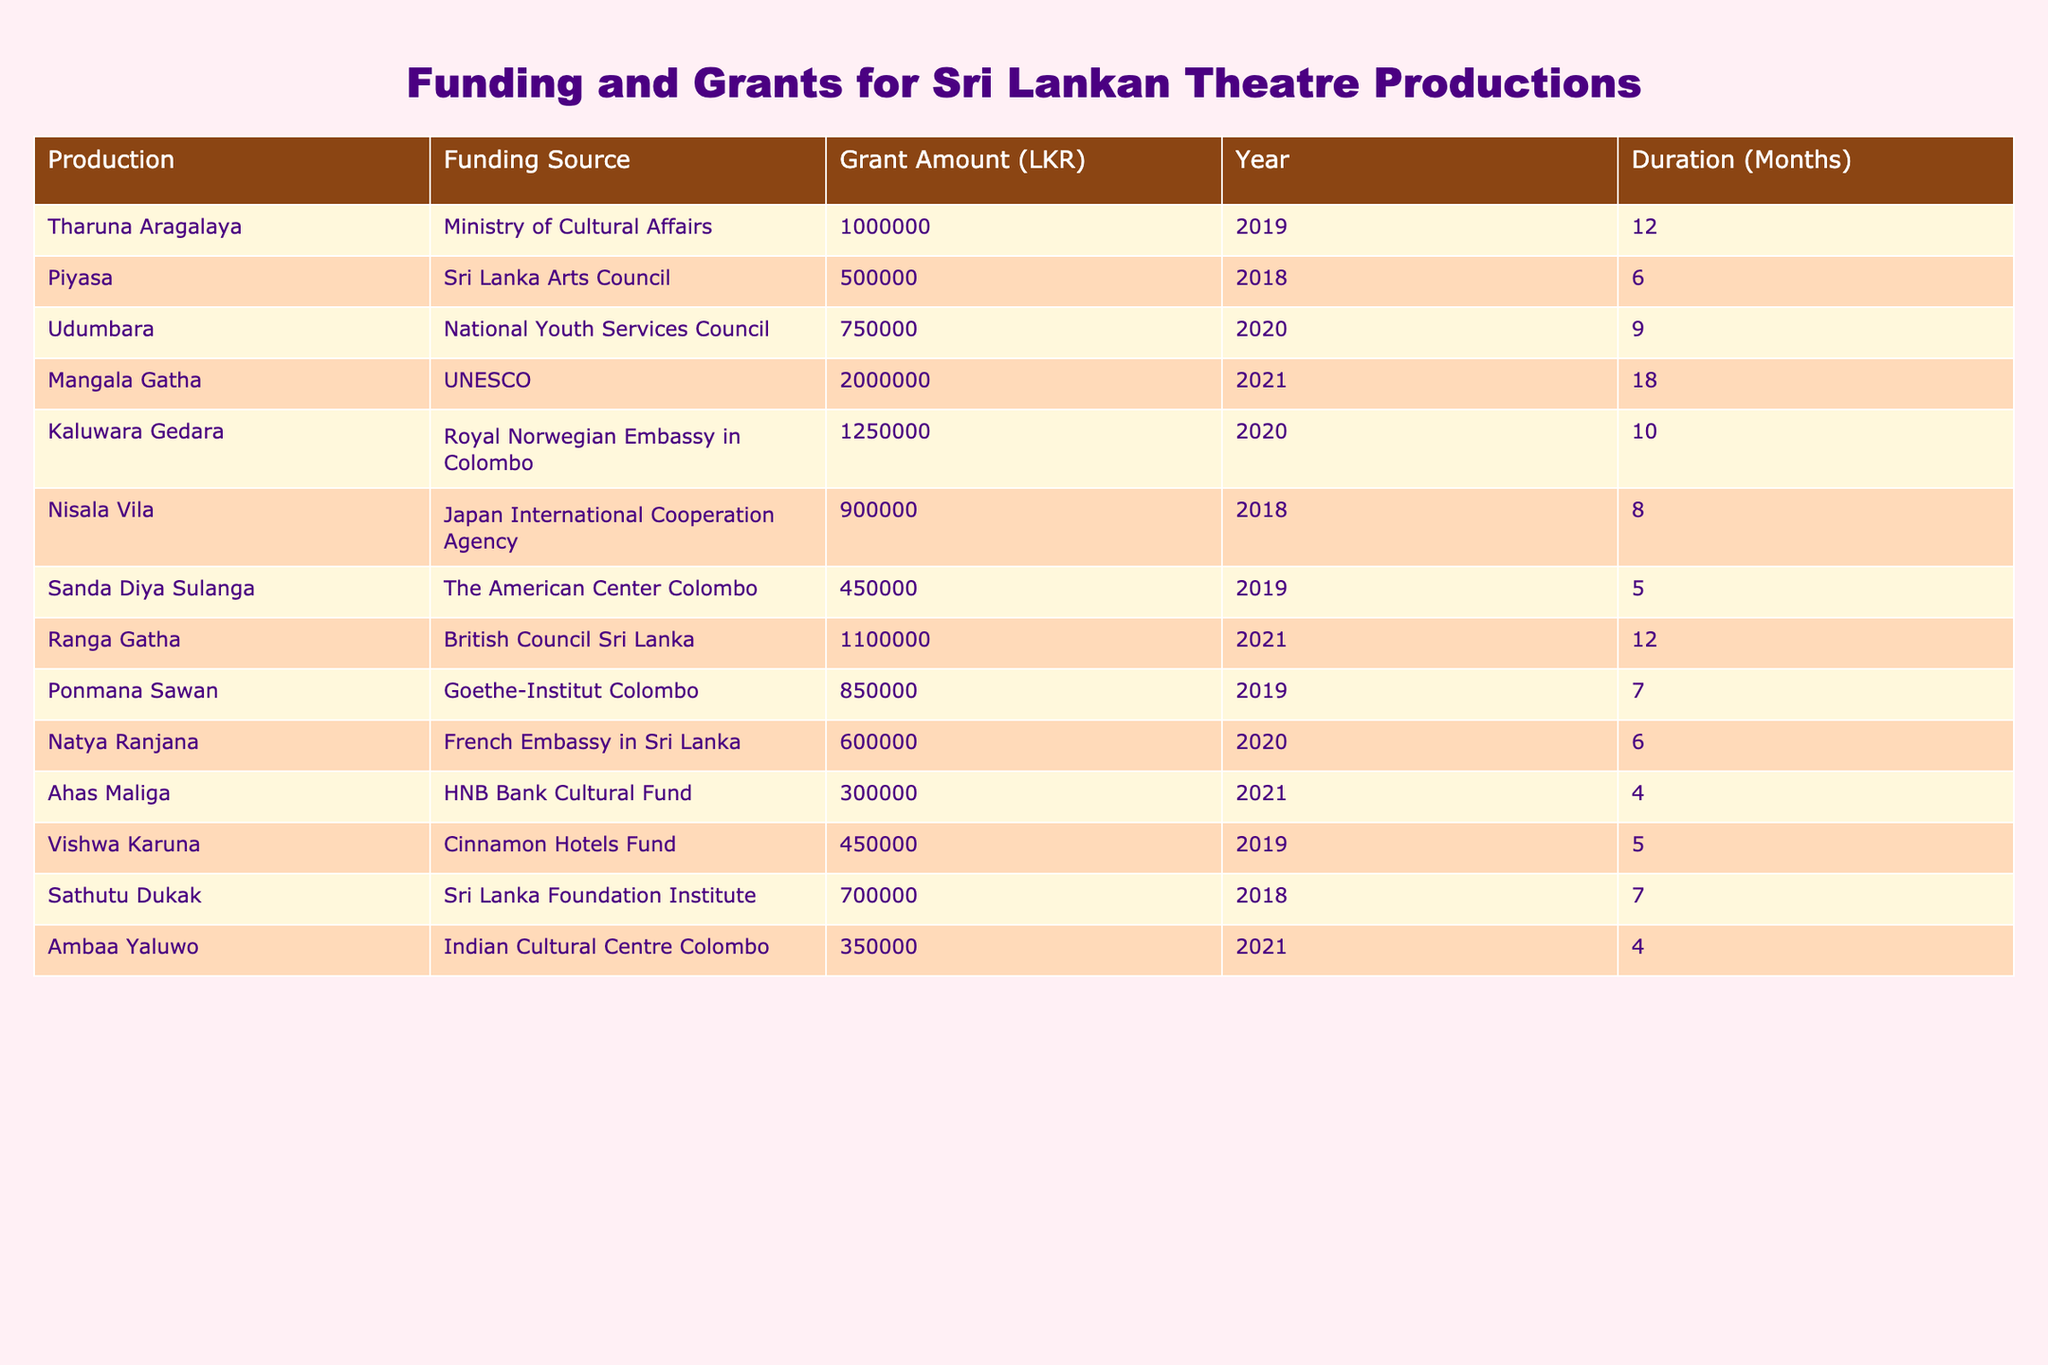What is the total grant amount received by the production "Mangala Gatha"? The table indicates that "Mangala Gatha" received a grant amount of 2,000,000 LKR from UNESCO.
Answer: 2,000,000 LKR Which production received funding from the Indian Cultural Centre Colombo? According to the table, "Ambaa Yaluwo" received funding from the Indian Cultural Centre Colombo, amounting to 350,000 LKR.
Answer: Ambaa Yaluwo How many months did the production "Kaluwara Gedara" receive funding for? The table shows that "Kaluwara Gedara" was funded for a duration of 10 months.
Answer: 10 months What is the average grant amount received by productions in the year 2020? The grants for 2020 are 750,000 LKR (Udumbara), 1,250,000 LKR (Kaluwara Gedara), 600,000 LKR (Natya Ranjana). The total is 2,600,000 LKR. In total, there are 3 productions. Hence, the average is 2,600,000 LKR / 3 = 866,666.67 LKR.
Answer: 866,666.67 LKR Did any production receive funding from the Ministry of Cultural Affairs? Yes, "Tharuna Aragalaya" received funding from the Ministry of Cultural Affairs, amounting to 1,000,000 LKR.
Answer: Yes Which production received the highest grant amount? The table indicates that "Mangala Gatha" received the highest grant of 2,000,000 LKR from UNESCO.
Answer: Mangala Gatha What is the combined funding received by the productions from the Sri Lanka Arts Council and the National Youth Services Council? From the table, "Piyasa" received 500,000 LKR from the Sri Lanka Arts Council, and "Udumbara" received 750,000 LKR from the National Youth Services Council. Combining these amounts gives 500,000 LKR + 750,000 LKR = 1,250,000 LKR.
Answer: 1,250,000 LKR How many productions received a grant amount greater than 1,000,000 LKR? The table shows that "Mangala Gatha" (2,000,000 LKR) and "Ranga Gatha" (1,100,000 LKR) are the only productions that received more than 1,000,000 LKR. Therefore, there are 2 such productions.
Answer: 2 Was the production "Vishwa Karuna" funded for more than 5 months? Yes, "Vishwa Karuna" was funded for a duration of 5 months. Since the question asks for "more than," the answer is false.
Answer: No 